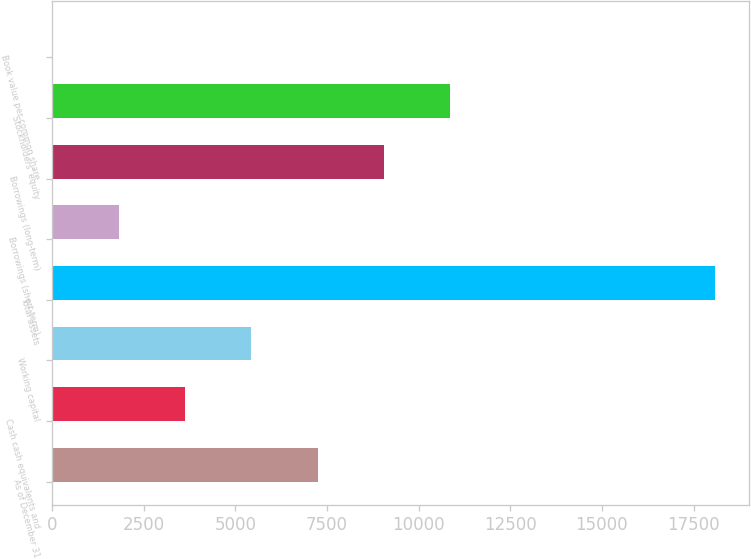<chart> <loc_0><loc_0><loc_500><loc_500><bar_chart><fcel>As of December 31<fcel>Cash cash equivalents and<fcel>Working capital<fcel>Total assets<fcel>Borrowings (short-term)<fcel>Borrowings (long-term)<fcel>Stockholders' equity<fcel>Book value per common share<nl><fcel>7241.38<fcel>3623.16<fcel>5432.27<fcel>18096<fcel>1814.05<fcel>9050.49<fcel>10859.6<fcel>4.94<nl></chart> 